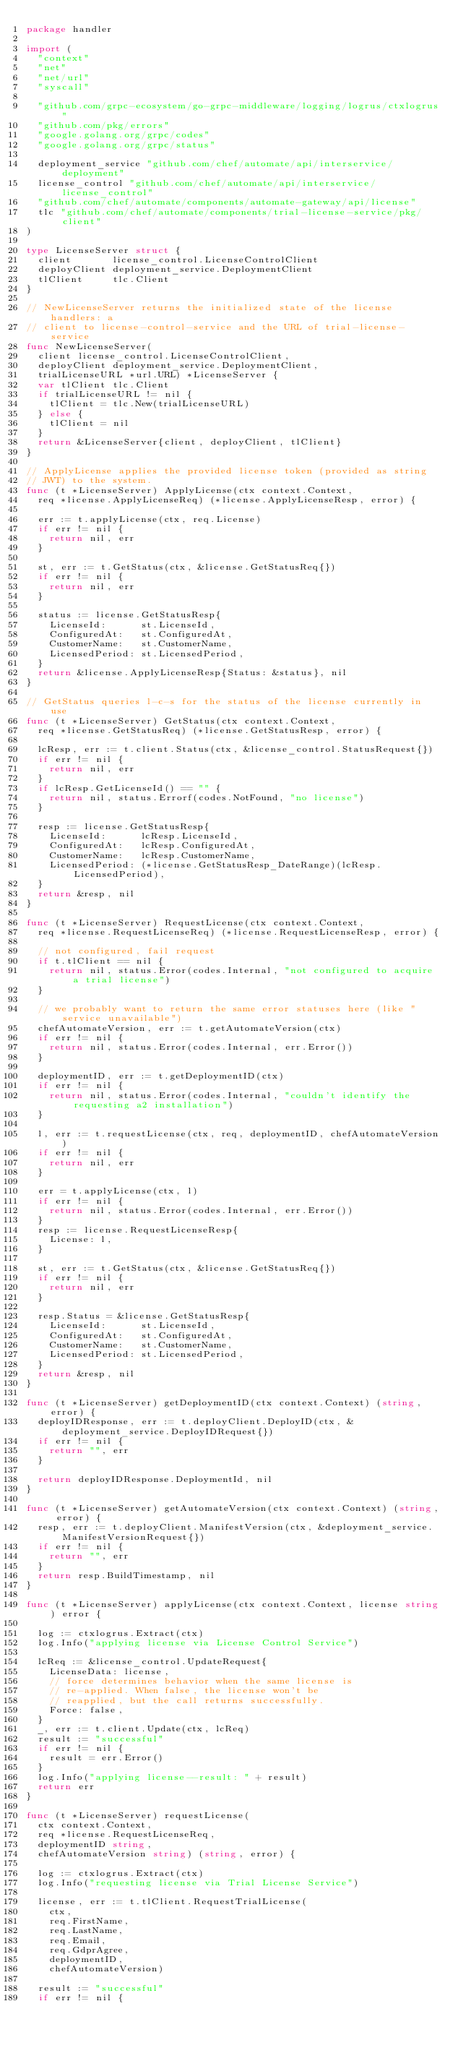<code> <loc_0><loc_0><loc_500><loc_500><_Go_>package handler

import (
	"context"
	"net"
	"net/url"
	"syscall"

	"github.com/grpc-ecosystem/go-grpc-middleware/logging/logrus/ctxlogrus"
	"github.com/pkg/errors"
	"google.golang.org/grpc/codes"
	"google.golang.org/grpc/status"

	deployment_service "github.com/chef/automate/api/interservice/deployment"
	license_control "github.com/chef/automate/api/interservice/license_control"
	"github.com/chef/automate/components/automate-gateway/api/license"
	tlc "github.com/chef/automate/components/trial-license-service/pkg/client"
)

type LicenseServer struct {
	client       license_control.LicenseControlClient
	deployClient deployment_service.DeploymentClient
	tlClient     tlc.Client
}

// NewLicenseServer returns the initialized state of the license handlers: a
// client to license-control-service and the URL of trial-license-service
func NewLicenseServer(
	client license_control.LicenseControlClient,
	deployClient deployment_service.DeploymentClient,
	trialLicenseURL *url.URL) *LicenseServer {
	var tlClient tlc.Client
	if trialLicenseURL != nil {
		tlClient = tlc.New(trialLicenseURL)
	} else {
		tlClient = nil
	}
	return &LicenseServer{client, deployClient, tlClient}
}

// ApplyLicense applies the provided license token (provided as string
// JWT) to the system.
func (t *LicenseServer) ApplyLicense(ctx context.Context,
	req *license.ApplyLicenseReq) (*license.ApplyLicenseResp, error) {

	err := t.applyLicense(ctx, req.License)
	if err != nil {
		return nil, err
	}

	st, err := t.GetStatus(ctx, &license.GetStatusReq{})
	if err != nil {
		return nil, err
	}

	status := license.GetStatusResp{
		LicenseId:      st.LicenseId,
		ConfiguredAt:   st.ConfiguredAt,
		CustomerName:   st.CustomerName,
		LicensedPeriod: st.LicensedPeriod,
	}
	return &license.ApplyLicenseResp{Status: &status}, nil
}

// GetStatus queries l-c-s for the status of the license currently in use
func (t *LicenseServer) GetStatus(ctx context.Context,
	req *license.GetStatusReq) (*license.GetStatusResp, error) {

	lcResp, err := t.client.Status(ctx, &license_control.StatusRequest{})
	if err != nil {
		return nil, err
	}
	if lcResp.GetLicenseId() == "" {
		return nil, status.Errorf(codes.NotFound, "no license")
	}

	resp := license.GetStatusResp{
		LicenseId:      lcResp.LicenseId,
		ConfiguredAt:   lcResp.ConfiguredAt,
		CustomerName:   lcResp.CustomerName,
		LicensedPeriod: (*license.GetStatusResp_DateRange)(lcResp.LicensedPeriod),
	}
	return &resp, nil
}

func (t *LicenseServer) RequestLicense(ctx context.Context,
	req *license.RequestLicenseReq) (*license.RequestLicenseResp, error) {

	// not configured, fail request
	if t.tlClient == nil {
		return nil, status.Error(codes.Internal, "not configured to acquire a trial license")
	}

	// we probably want to return the same error statuses here (like "service unavailable")
	chefAutomateVersion, err := t.getAutomateVersion(ctx)
	if err != nil {
		return nil, status.Error(codes.Internal, err.Error())
	}

	deploymentID, err := t.getDeploymentID(ctx)
	if err != nil {
		return nil, status.Error(codes.Internal, "couldn't identify the requesting a2 installation")
	}

	l, err := t.requestLicense(ctx, req, deploymentID, chefAutomateVersion)
	if err != nil {
		return nil, err
	}

	err = t.applyLicense(ctx, l)
	if err != nil {
		return nil, status.Error(codes.Internal, err.Error())
	}
	resp := license.RequestLicenseResp{
		License: l,
	}

	st, err := t.GetStatus(ctx, &license.GetStatusReq{})
	if err != nil {
		return nil, err
	}

	resp.Status = &license.GetStatusResp{
		LicenseId:      st.LicenseId,
		ConfiguredAt:   st.ConfiguredAt,
		CustomerName:   st.CustomerName,
		LicensedPeriod: st.LicensedPeriod,
	}
	return &resp, nil
}

func (t *LicenseServer) getDeploymentID(ctx context.Context) (string, error) {
	deployIDResponse, err := t.deployClient.DeployID(ctx, &deployment_service.DeployIDRequest{})
	if err != nil {
		return "", err
	}

	return deployIDResponse.DeploymentId, nil
}

func (t *LicenseServer) getAutomateVersion(ctx context.Context) (string, error) {
	resp, err := t.deployClient.ManifestVersion(ctx, &deployment_service.ManifestVersionRequest{})
	if err != nil {
		return "", err
	}
	return resp.BuildTimestamp, nil
}

func (t *LicenseServer) applyLicense(ctx context.Context, license string) error {

	log := ctxlogrus.Extract(ctx)
	log.Info("applying license via License Control Service")

	lcReq := &license_control.UpdateRequest{
		LicenseData: license,
		// force determines behavior when the same license is
		// re-applied. When false, the license won't be
		// reapplied, but the call returns successfully.
		Force: false,
	}
	_, err := t.client.Update(ctx, lcReq)
	result := "successful"
	if err != nil {
		result = err.Error()
	}
	log.Info("applying license--result: " + result)
	return err
}

func (t *LicenseServer) requestLicense(
	ctx context.Context,
	req *license.RequestLicenseReq,
	deploymentID string,
	chefAutomateVersion string) (string, error) {

	log := ctxlogrus.Extract(ctx)
	log.Info("requesting license via Trial License Service")

	license, err := t.tlClient.RequestTrialLicense(
		ctx,
		req.FirstName,
		req.LastName,
		req.Email,
		req.GdprAgree,
		deploymentID,
		chefAutomateVersion)

	result := "successful"
	if err != nil {</code> 